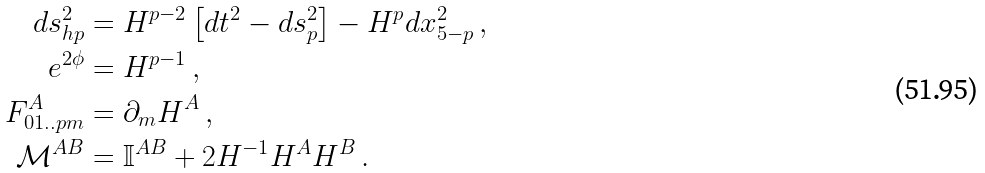<formula> <loc_0><loc_0><loc_500><loc_500>d s ^ { 2 } _ { h p } & = { H } ^ { p - 2 } \left [ d t ^ { 2 } - d s _ { p } ^ { 2 } \right ] - { H } ^ { p } d x _ { 5 - p } ^ { 2 } \, , \\ e ^ { 2 \phi } & = { H } ^ { p - 1 } \, , \\ F ^ { A } _ { 0 1 . . p m } & = \partial _ { m } H ^ { A } \, , \\ \mathcal { M } ^ { A B } & = \mathbb { I } ^ { A B } + 2 { H } ^ { - 1 } H ^ { A } H ^ { B } \, .</formula> 